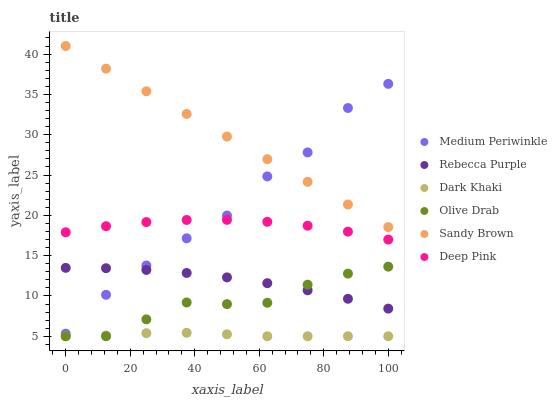Does Dark Khaki have the minimum area under the curve?
Answer yes or no. Yes. Does Sandy Brown have the maximum area under the curve?
Answer yes or no. Yes. Does Medium Periwinkle have the minimum area under the curve?
Answer yes or no. No. Does Medium Periwinkle have the maximum area under the curve?
Answer yes or no. No. Is Sandy Brown the smoothest?
Answer yes or no. Yes. Is Medium Periwinkle the roughest?
Answer yes or no. Yes. Is Dark Khaki the smoothest?
Answer yes or no. No. Is Dark Khaki the roughest?
Answer yes or no. No. Does Dark Khaki have the lowest value?
Answer yes or no. Yes. Does Medium Periwinkle have the lowest value?
Answer yes or no. No. Does Sandy Brown have the highest value?
Answer yes or no. Yes. Does Medium Periwinkle have the highest value?
Answer yes or no. No. Is Rebecca Purple less than Sandy Brown?
Answer yes or no. Yes. Is Medium Periwinkle greater than Olive Drab?
Answer yes or no. Yes. Does Dark Khaki intersect Olive Drab?
Answer yes or no. Yes. Is Dark Khaki less than Olive Drab?
Answer yes or no. No. Is Dark Khaki greater than Olive Drab?
Answer yes or no. No. Does Rebecca Purple intersect Sandy Brown?
Answer yes or no. No. 